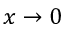Convert formula to latex. <formula><loc_0><loc_0><loc_500><loc_500>x \to 0</formula> 